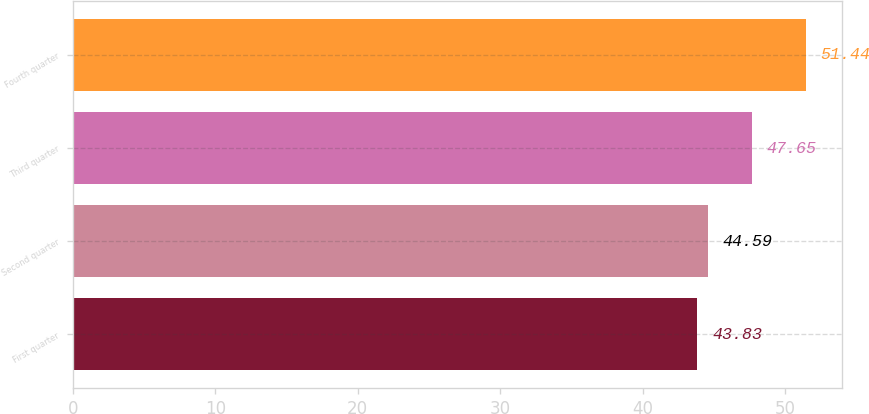Convert chart to OTSL. <chart><loc_0><loc_0><loc_500><loc_500><bar_chart><fcel>First quarter<fcel>Second quarter<fcel>Third quarter<fcel>Fourth quarter<nl><fcel>43.83<fcel>44.59<fcel>47.65<fcel>51.44<nl></chart> 